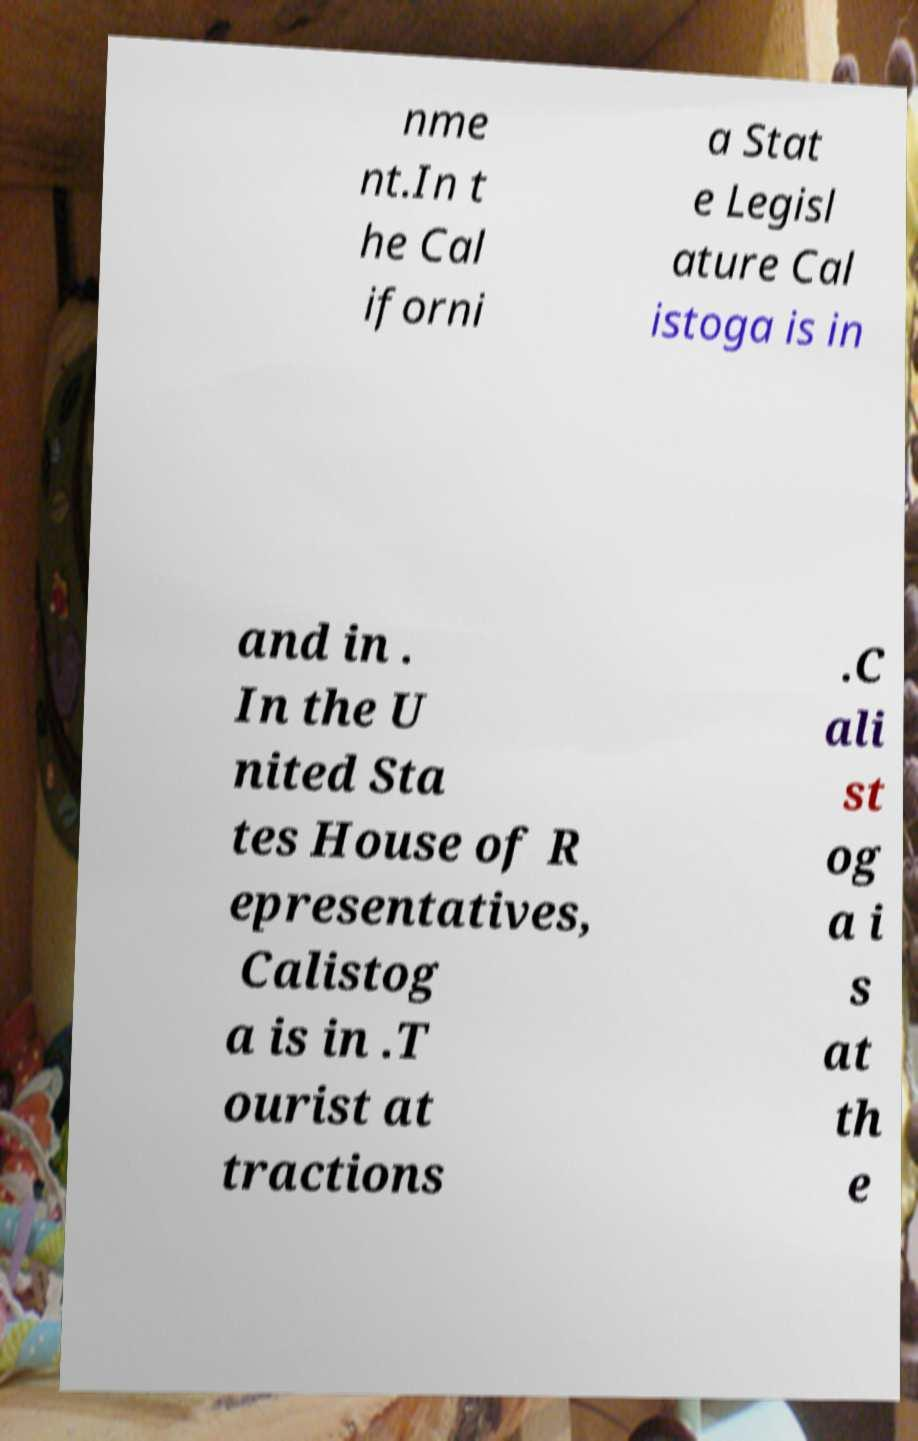Could you assist in decoding the text presented in this image and type it out clearly? nme nt.In t he Cal iforni a Stat e Legisl ature Cal istoga is in and in . In the U nited Sta tes House of R epresentatives, Calistog a is in .T ourist at tractions .C ali st og a i s at th e 